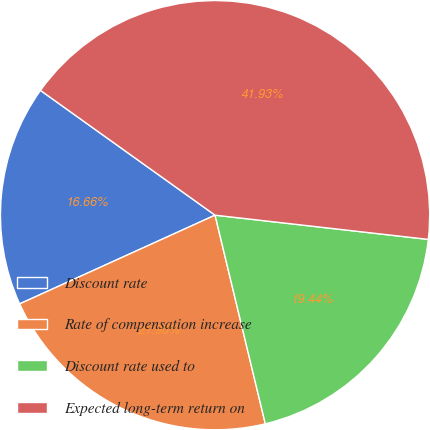Convert chart. <chart><loc_0><loc_0><loc_500><loc_500><pie_chart><fcel>Discount rate<fcel>Rate of compensation increase<fcel>Discount rate used to<fcel>Expected long-term return on<nl><fcel>16.66%<fcel>21.98%<fcel>19.44%<fcel>41.93%<nl></chart> 